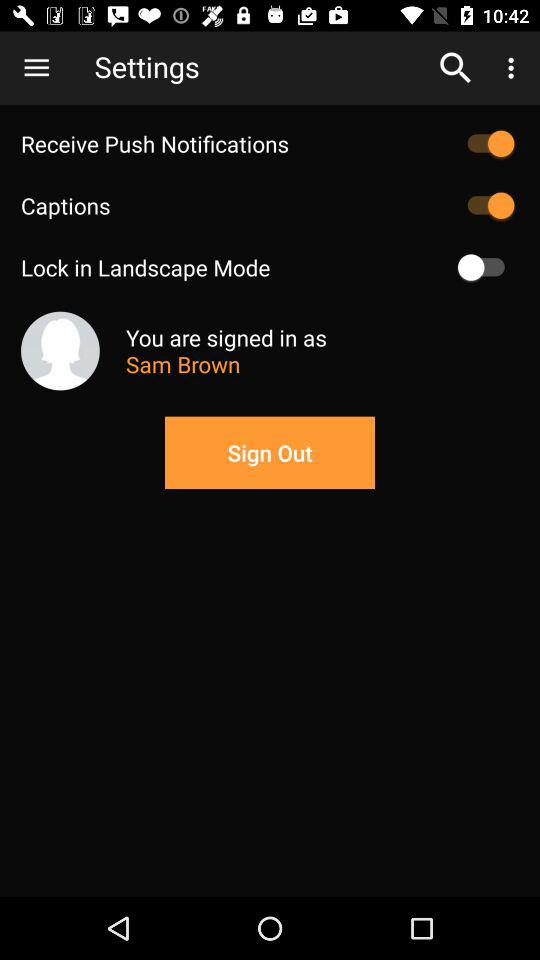How many switches are there in the settings menu?
Answer the question using a single word or phrase. 3 